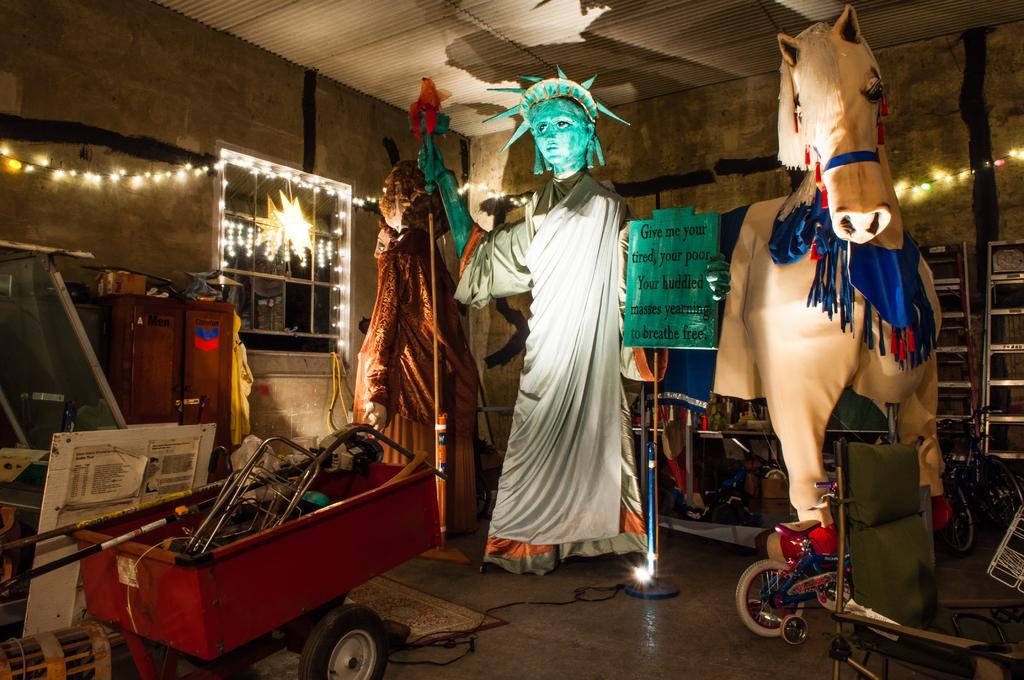Can you describe this image briefly? In this image there is statue of liberty toy in the middle. At the bottom there is a trolley in which there are machines. On the right side there is a horse mask. In between them there is a ole. At the top there is ceiling. There is a star attached to the window. There is a light in the star. It seems like a store room. 